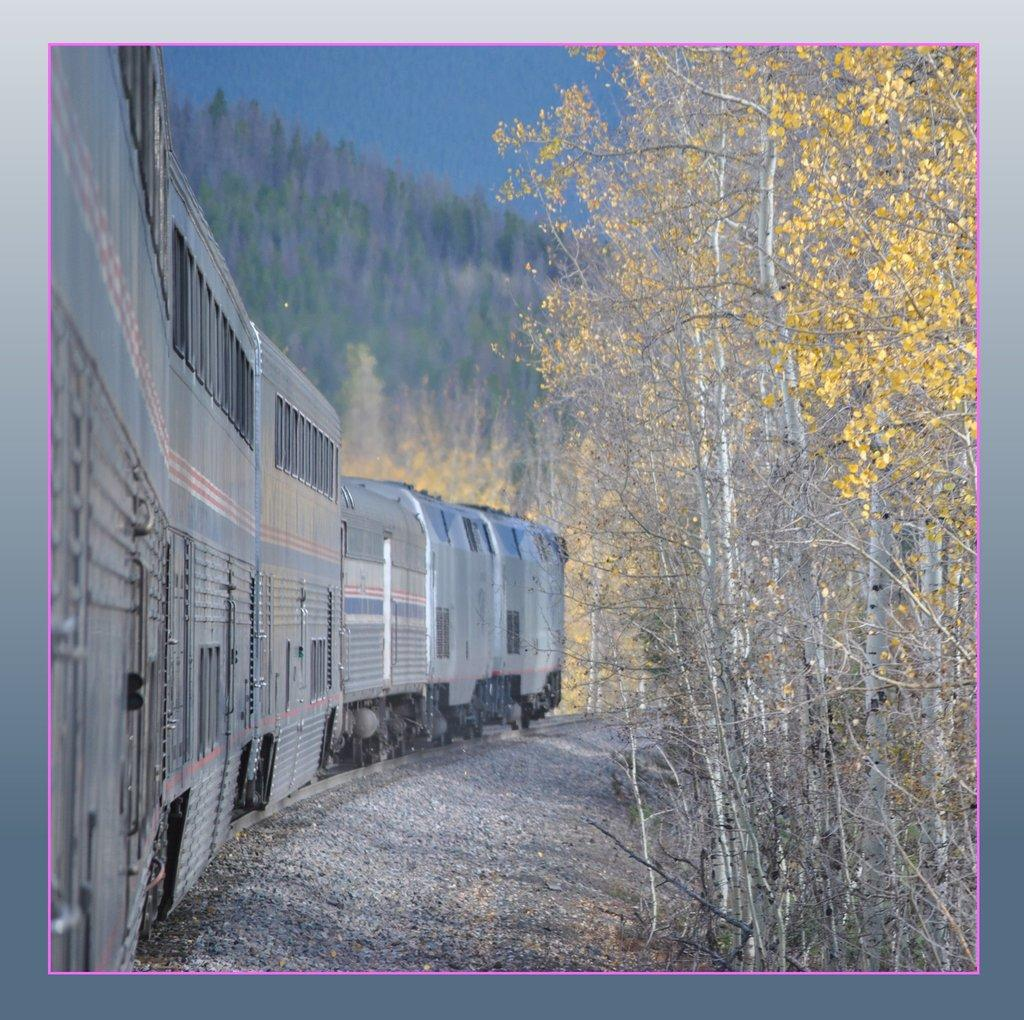What object is present in the image that typically holds a photograph? There is a photo frame in the image. What mode of transportation can be seen in the image? There is a train on a railway track in the image. What type of vegetation is on the right side of the image? There are trees on the right side of the image. How would you describe the overall clarity of the image? The background of the image is blurry. What else can be seen in the background of the image besides the blurry area? There are trees visible in the background of the image. Can you tell me how many deer are visible in the image? There are no deer present in the image. What type of branch is holding the train on the railway track? There is no branch holding the train on the railway track; it is supported by the tracks themselves. 